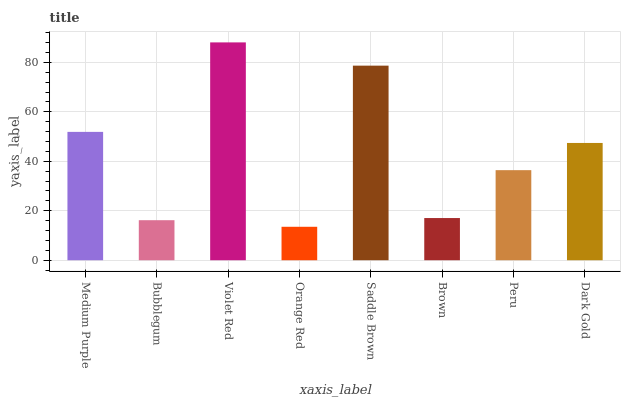Is Orange Red the minimum?
Answer yes or no. Yes. Is Violet Red the maximum?
Answer yes or no. Yes. Is Bubblegum the minimum?
Answer yes or no. No. Is Bubblegum the maximum?
Answer yes or no. No. Is Medium Purple greater than Bubblegum?
Answer yes or no. Yes. Is Bubblegum less than Medium Purple?
Answer yes or no. Yes. Is Bubblegum greater than Medium Purple?
Answer yes or no. No. Is Medium Purple less than Bubblegum?
Answer yes or no. No. Is Dark Gold the high median?
Answer yes or no. Yes. Is Peru the low median?
Answer yes or no. Yes. Is Peru the high median?
Answer yes or no. No. Is Dark Gold the low median?
Answer yes or no. No. 